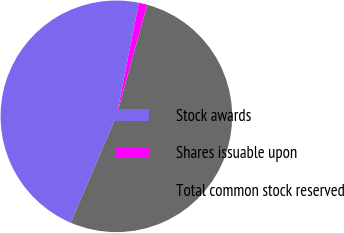Convert chart. <chart><loc_0><loc_0><loc_500><loc_500><pie_chart><fcel>Stock awards<fcel>Shares issuable upon<fcel>Total common stock reserved<nl><fcel>46.67%<fcel>1.18%<fcel>52.16%<nl></chart> 